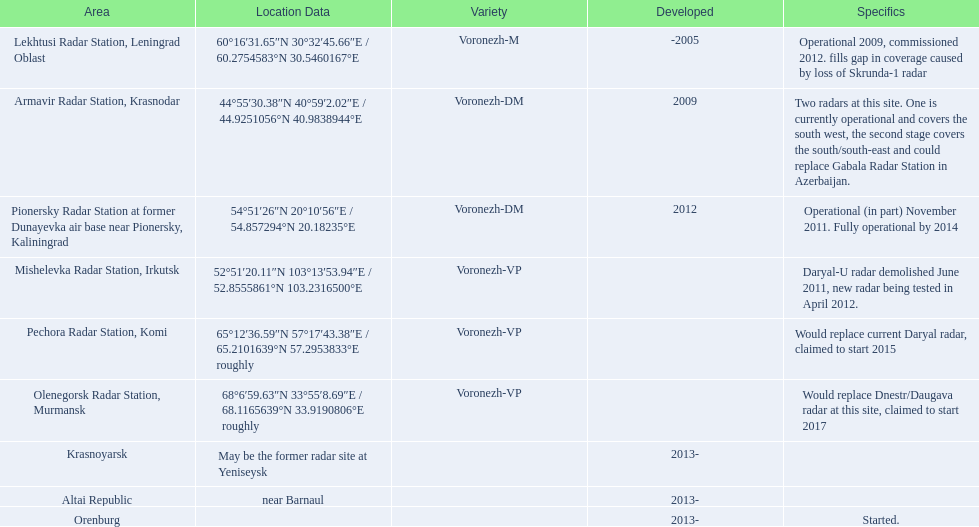Voronezh radar has locations where? Lekhtusi Radar Station, Leningrad Oblast, Armavir Radar Station, Krasnodar, Pionersky Radar Station at former Dunayevka air base near Pionersky, Kaliningrad, Mishelevka Radar Station, Irkutsk, Pechora Radar Station, Komi, Olenegorsk Radar Station, Murmansk, Krasnoyarsk, Altai Republic, Orenburg. Which of these locations have know coordinates? Lekhtusi Radar Station, Leningrad Oblast, Armavir Radar Station, Krasnodar, Pionersky Radar Station at former Dunayevka air base near Pionersky, Kaliningrad, Mishelevka Radar Station, Irkutsk, Pechora Radar Station, Komi, Olenegorsk Radar Station, Murmansk. Which of these locations has coordinates of 60deg16'31.65''n 30deg32'45.66''e / 60.2754583degn 30.5460167dege? Lekhtusi Radar Station, Leningrad Oblast. 